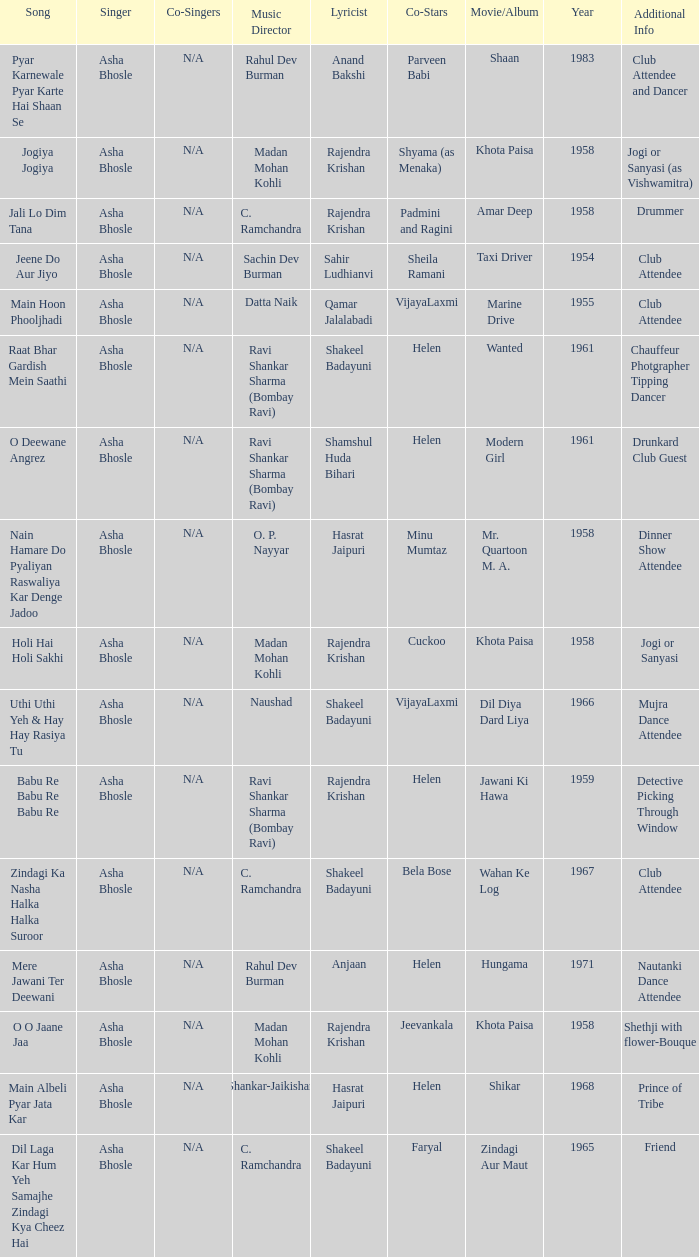Could you help me parse every detail presented in this table? {'header': ['Song', 'Singer', 'Co-Singers', 'Music Director', 'Lyricist', 'Co-Stars', 'Movie/Album', 'Year', 'Additional Info'], 'rows': [['Pyar Karnewale Pyar Karte Hai Shaan Se', 'Asha Bhosle', 'N/A', 'Rahul Dev Burman', 'Anand Bakshi', 'Parveen Babi', 'Shaan', '1983', 'Club Attendee and Dancer'], ['Jogiya Jogiya', 'Asha Bhosle', 'N/A', 'Madan Mohan Kohli', 'Rajendra Krishan', 'Shyama (as Menaka)', 'Khota Paisa', '1958', 'Jogi or Sanyasi (as Vishwamitra)'], ['Jali Lo Dim Tana', 'Asha Bhosle', 'N/A', 'C. Ramchandra', 'Rajendra Krishan', 'Padmini and Ragini', 'Amar Deep', '1958', 'Drummer'], ['Jeene Do Aur Jiyo', 'Asha Bhosle', 'N/A', 'Sachin Dev Burman', 'Sahir Ludhianvi', 'Sheila Ramani', 'Taxi Driver', '1954', 'Club Attendee'], ['Main Hoon Phooljhadi', 'Asha Bhosle', 'N/A', 'Datta Naik', 'Qamar Jalalabadi', 'VijayaLaxmi', 'Marine Drive', '1955', 'Club Attendee'], ['Raat Bhar Gardish Mein Saathi', 'Asha Bhosle', 'N/A', 'Ravi Shankar Sharma (Bombay Ravi)', 'Shakeel Badayuni', 'Helen', 'Wanted', '1961', 'Chauffeur Photgrapher Tipping Dancer'], ['O Deewane Angrez', 'Asha Bhosle', 'N/A', 'Ravi Shankar Sharma (Bombay Ravi)', 'Shamshul Huda Bihari', 'Helen', 'Modern Girl', '1961', 'Drunkard Club Guest'], ['Nain Hamare Do Pyaliyan Raswaliya Kar Denge Jadoo', 'Asha Bhosle', 'N/A', 'O. P. Nayyar', 'Hasrat Jaipuri', 'Minu Mumtaz', 'Mr. Quartoon M. A.', '1958', 'Dinner Show Attendee'], ['Holi Hai Holi Sakhi', 'Asha Bhosle', 'N/A', 'Madan Mohan Kohli', 'Rajendra Krishan', 'Cuckoo', 'Khota Paisa', '1958', 'Jogi or Sanyasi'], ['Uthi Uthi Yeh & Hay Hay Rasiya Tu', 'Asha Bhosle', 'N/A', 'Naushad', 'Shakeel Badayuni', 'VijayaLaxmi', 'Dil Diya Dard Liya', '1966', 'Mujra Dance Attendee'], ['Babu Re Babu Re Babu Re', 'Asha Bhosle', 'N/A', 'Ravi Shankar Sharma (Bombay Ravi)', 'Rajendra Krishan', 'Helen', 'Jawani Ki Hawa', '1959', 'Detective Picking Through Window'], ['Zindagi Ka Nasha Halka Halka Suroor', 'Asha Bhosle', 'N/A', 'C. Ramchandra', 'Shakeel Badayuni', 'Bela Bose', 'Wahan Ke Log', '1967', 'Club Attendee'], ['Mere Jawani Ter Deewani', 'Asha Bhosle', 'N/A', 'Rahul Dev Burman', 'Anjaan', 'Helen', 'Hungama', '1971', 'Nautanki Dance Attendee'], ['O O Jaane Jaa', 'Asha Bhosle', 'N/A', 'Madan Mohan Kohli', 'Rajendra Krishan', 'Jeevankala', 'Khota Paisa', '1958', 'Shethji with flower-Bouque'], ['Main Albeli Pyar Jata Kar', 'Asha Bhosle', 'N/A', 'Shankar-Jaikishan', 'Hasrat Jaipuri', 'Helen', 'Shikar', '1968', 'Prince of Tribe'], ['Dil Laga Kar Hum Yeh Samajhe Zindagi Kya Cheez Hai', 'Asha Bhosle', 'N/A', 'C. Ramchandra', 'Shakeel Badayuni', 'Faryal', 'Zindagi Aur Maut', '1965', 'Friend']]} What movie did Bela Bose co-star in? Wahan Ke Log. 